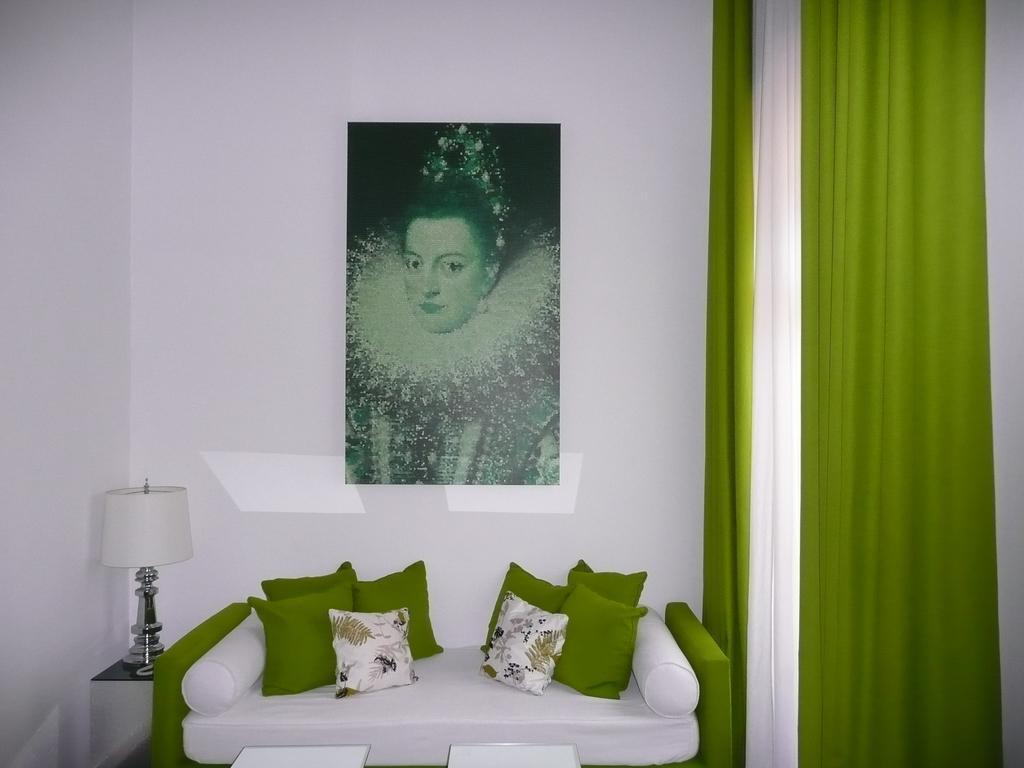Describe this image in one or two sentences. In the picture we can see a sofa, with pillows, three are green in colour and one is white and other side three pillows which are green and one is white, just beside the sofa we can find a lamp which is white in colour and steel stand on the table. In the background we can find a wall with some posters of women in it and we can also find a green and white curtains. 